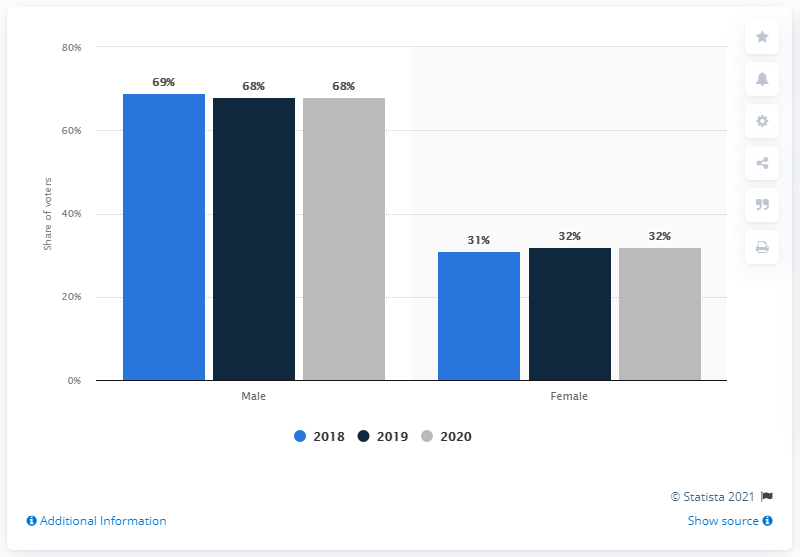Point out several critical features in this image. The grey bars represent the year 2020. In 2019, the difference in shares between male and female votes was 36%. 